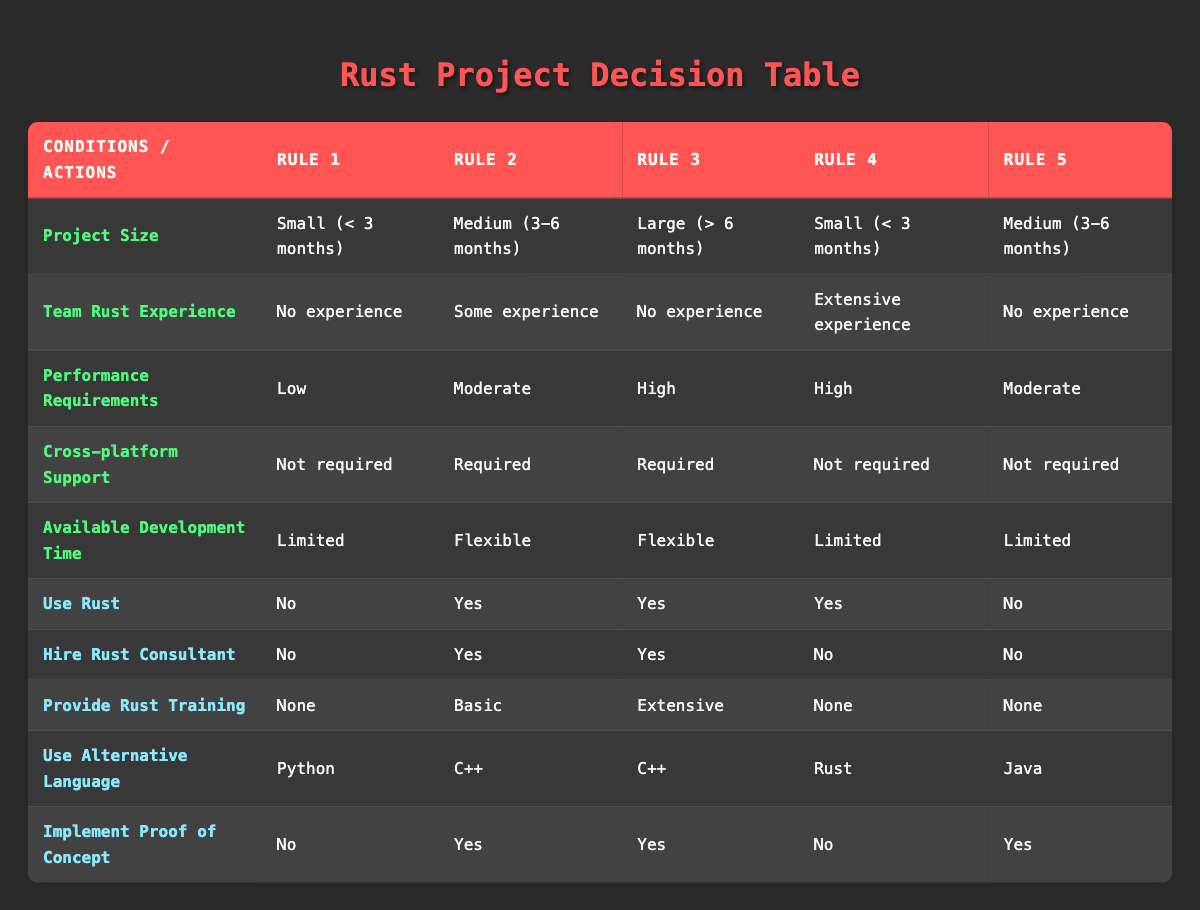What language is recommended if the project size is small and the team has no Rust experience? From Rule 1, under the conditions where the project size is small and the team has no experience in Rust, the recommended alternative language is Python.
Answer: Python Is hiring a Rust consultant necessary for projects with high performance requirements and no team experience? According to Rule 3, for a large project with high performance requirements and no experience in Rust, hiring a Rust consultant is necessary (Yes).
Answer: Yes Which rules suggest providing basic Rust training? From Rule 2, where the project size is medium with some experience in Rust, it specifies providing basic training. The same applies to Rule 5, where the project size is medium with no experience and limited time, less explicit training is given.
Answer: Rule 2 What are the performance requirements for projects that use Rust? Review Rules 2, 3, and 4: Rules 2 and 3 indicate the performance requirements can be moderate or high. Rule 4 specifies the conditions still use Rust even with high performance requirement. Thus, performance can be high or moderate for using Rust.
Answer: Moderate or High Is implementing a proof of concept necessary if the project is medium-sized, has some experience with Rust, and requires cross-platform support? Yes, from Rule 2, where the conditions specify that a proof of concept is needed for projects that are medium-sized, have some Rust experience, and require cross-platform support.
Answer: Yes Are projects with small size and extensive experience recommended to use an alternative language? Rule 4 shows that even though there is extensive experience, the usage of Rust is confirmed, and thus no alternative language is suggested.
Answer: No If a project has flexible development time and high performance requirements, what actions might be taken? Considering both Rules 3 and 2: Actions suggested include using Rust, hiring a consultant, providing training (either extensive for Rule 3 or basic for Rule 2), and implementing a proof of concept within flexible timelines.
Answer: Use Rust and implement proof of concept What total number of rules require hiring a Rust consultant? By examining the rules, hiring a Rust consultant is necessary in Rules 2 and 3, resulting in a total of 2 rules where hiring is required.
Answer: 2 Is it possible for a project to not use Rust and still require cross-platform support? Rule 1 shows that projects can choose not to use Rust, especially for small projects with low-performance requirements and no cross-platform need. But, in cases like Rules 2 and 3—where there is cross-platform support—Rust is used. Hence, it is mostly connected to project size and type.
Answer: Yes 